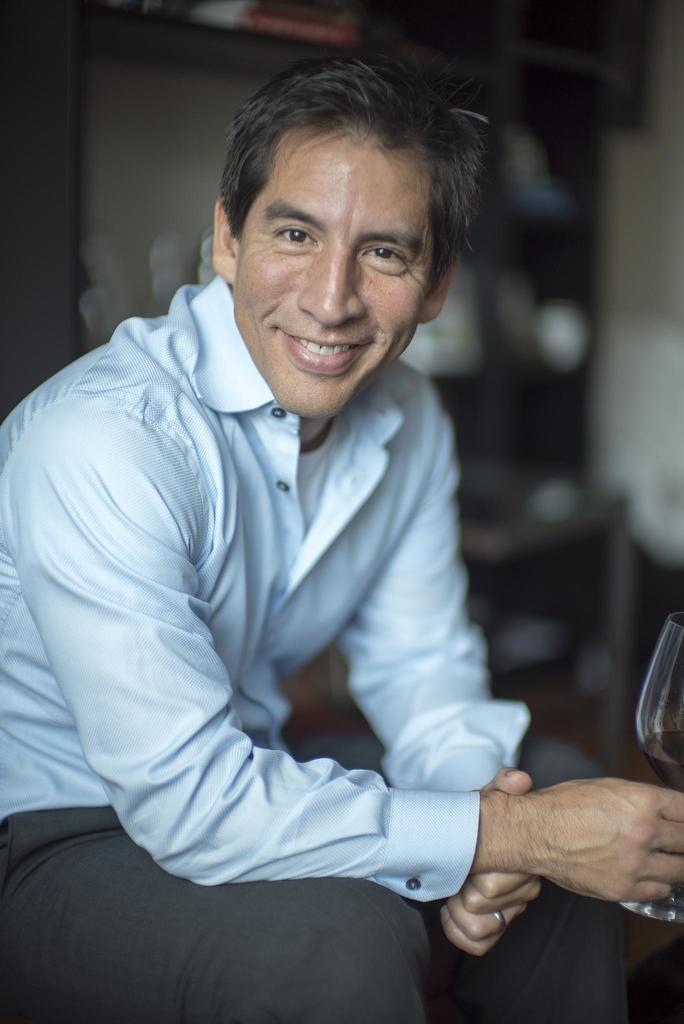Can you describe this image briefly? Here we can see a man sitting with a glass in his hand and he is smiling 